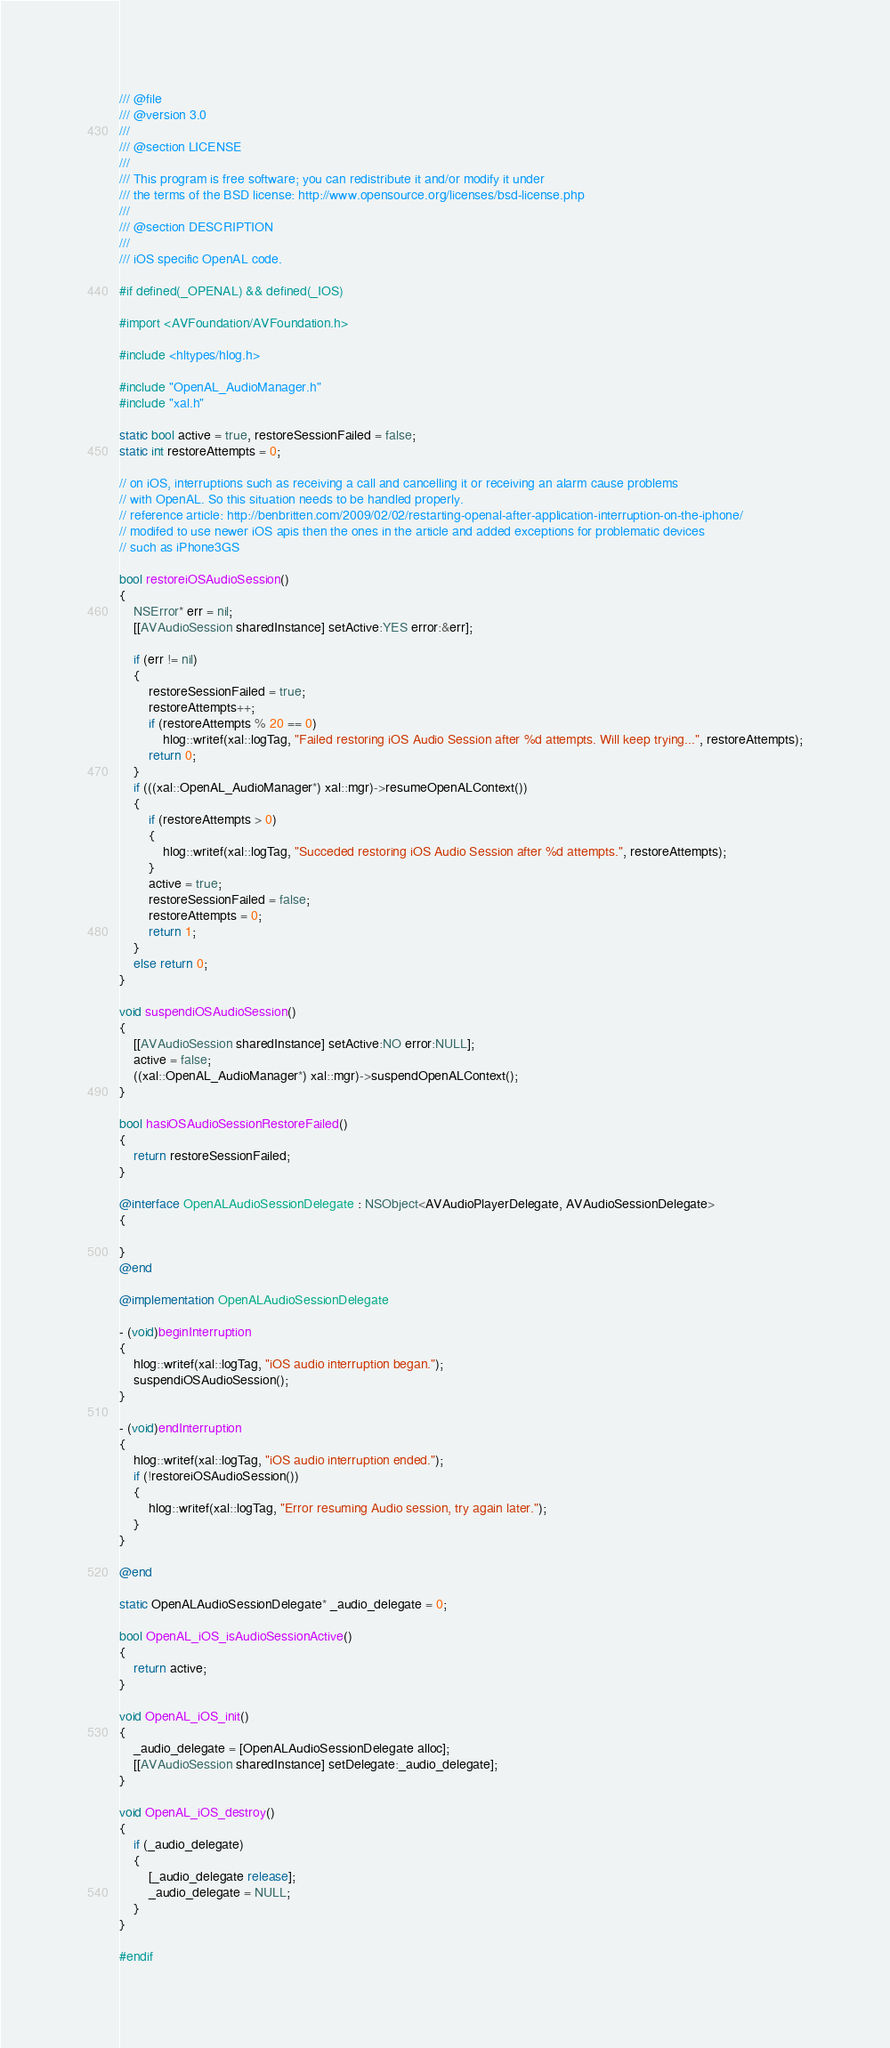Convert code to text. <code><loc_0><loc_0><loc_500><loc_500><_ObjectiveC_>/// @file
/// @version 3.0
/// 
/// @section LICENSE
/// 
/// This program is free software; you can redistribute it and/or modify it under
/// the terms of the BSD license: http://www.opensource.org/licenses/bsd-license.php
/// 
/// @section DESCRIPTION
/// 
/// iOS specific OpenAL code.

#if defined(_OPENAL) && defined(_IOS)

#import <AVFoundation/AVFoundation.h>

#include <hltypes/hlog.h>

#include "OpenAL_AudioManager.h"
#include "xal.h"

static bool active = true, restoreSessionFailed = false;
static int restoreAttempts = 0;

// on iOS, interruptions such as receiving a call and cancelling it or receiving an alarm cause problems
// with OpenAL. So this situation needs to be handled properly. 
// reference article: http://benbritten.com/2009/02/02/restarting-openal-after-application-interruption-on-the-iphone/
// modifed to use newer iOS apis then the ones in the article and added exceptions for problematic devices
// such as iPhone3GS

bool restoreiOSAudioSession()
{
	NSError* err = nil;
	[[AVAudioSession sharedInstance] setActive:YES error:&err];

	if (err != nil)
	{
		restoreSessionFailed = true;
		restoreAttempts++;
		if (restoreAttempts % 20 == 0)
			hlog::writef(xal::logTag, "Failed restoring iOS Audio Session after %d attempts. Will keep trying...", restoreAttempts);
		return 0;
	}
	if (((xal::OpenAL_AudioManager*) xal::mgr)->resumeOpenALContext())
	{
		if (restoreAttempts > 0)
		{
			hlog::writef(xal::logTag, "Succeded restoring iOS Audio Session after %d attempts.", restoreAttempts);
		}
		active = true;
		restoreSessionFailed = false;
		restoreAttempts = 0;
		return 1;
	}
	else return 0;
}

void suspendiOSAudioSession()
{
	[[AVAudioSession sharedInstance] setActive:NO error:NULL];
	active = false;
	((xal::OpenAL_AudioManager*) xal::mgr)->suspendOpenALContext();
}

bool hasiOSAudioSessionRestoreFailed()
{
	return restoreSessionFailed;
}

@interface OpenALAudioSessionDelegate : NSObject<AVAudioPlayerDelegate, AVAudioSessionDelegate>
{

}
@end

@implementation OpenALAudioSessionDelegate

- (void)beginInterruption
{
	hlog::writef(xal::logTag, "iOS audio interruption began.");
	suspendiOSAudioSession();
}

- (void)endInterruption
{
	hlog::writef(xal::logTag, "iOS audio interruption ended.");
	if (!restoreiOSAudioSession())
	{
		hlog::writef(xal::logTag, "Error resuming Audio session, try again later.");
	}
}

@end

static OpenALAudioSessionDelegate* _audio_delegate = 0;

bool OpenAL_iOS_isAudioSessionActive()
{
	return active;
}

void OpenAL_iOS_init()
{
	_audio_delegate = [OpenALAudioSessionDelegate alloc];
	[[AVAudioSession sharedInstance] setDelegate:_audio_delegate];
}

void OpenAL_iOS_destroy()
{
	if (_audio_delegate)
	{
		[_audio_delegate release];
		_audio_delegate = NULL;
	}
}

#endif
</code> 